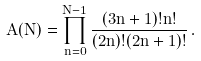Convert formula to latex. <formula><loc_0><loc_0><loc_500><loc_500>A ( N ) = \prod _ { n = 0 } ^ { N - 1 } \frac { ( 3 n + 1 ) ! n ! } { ( 2 n ) ! ( 2 n + 1 ) ! } \, .</formula> 